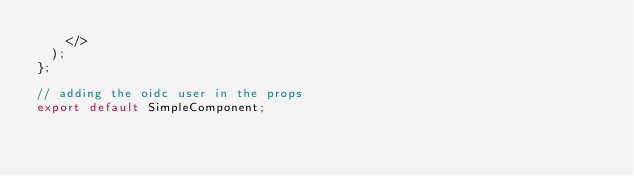<code> <loc_0><loc_0><loc_500><loc_500><_JavaScript_>    </>
  );
};

// adding the oidc user in the props
export default SimpleComponent;
</code> 